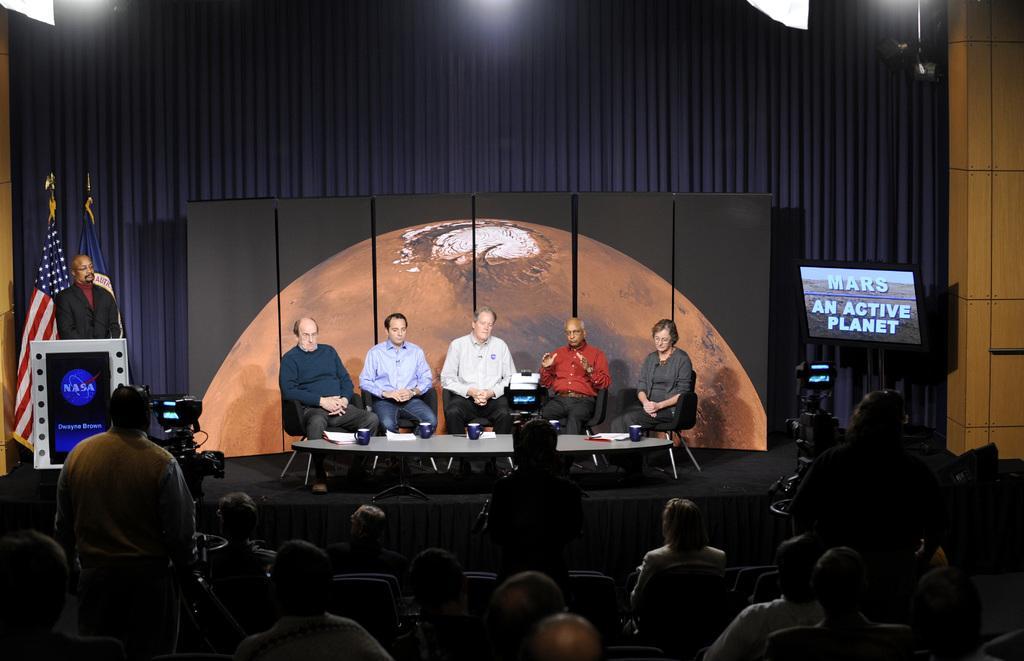Could you give a brief overview of what you see in this image? In this picture I can see a group of people are sitting at the bottom, in the middle few persons are sitting on the chairs. On the left side a man is standing near the camera and another man is standing near the podium. On the right side there is the television and also there is another camera. 